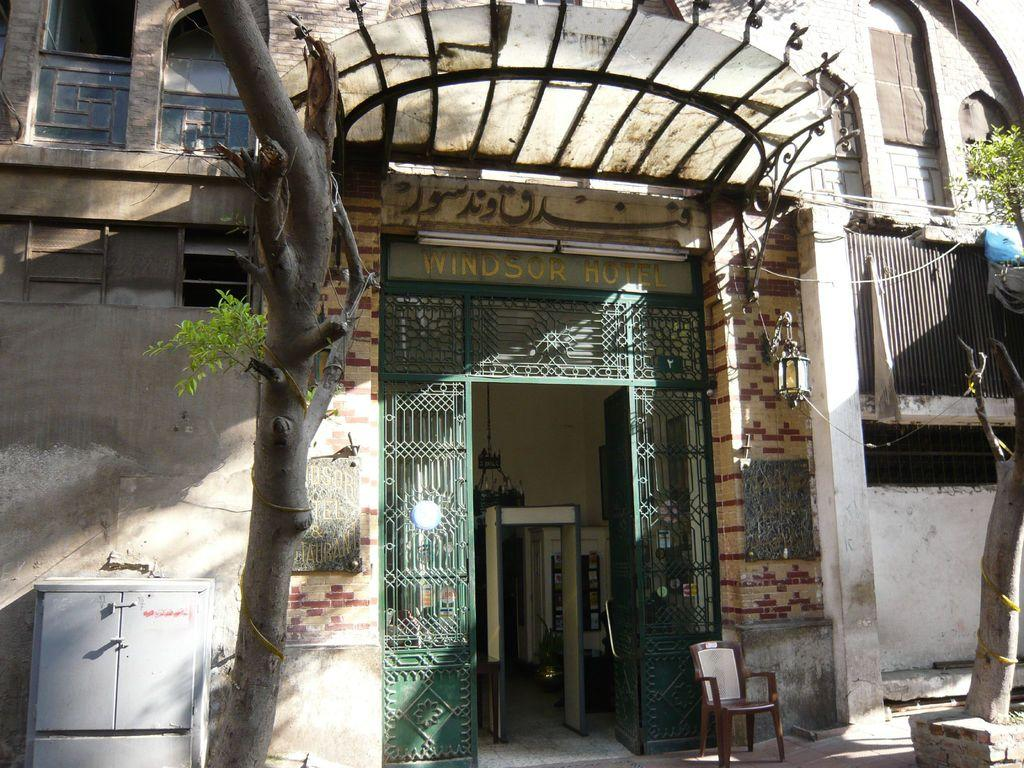<image>
Relay a brief, clear account of the picture shown. An entrance to the Windsor Hotel has green metal around it. 